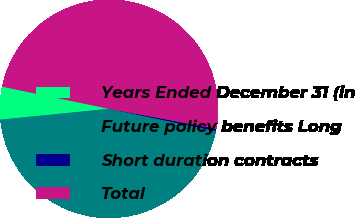<chart> <loc_0><loc_0><loc_500><loc_500><pie_chart><fcel>Years Ended December 31 (in<fcel>Future policy benefits Long<fcel>Short duration contracts<fcel>Total<nl><fcel>4.84%<fcel>45.16%<fcel>0.32%<fcel>49.68%<nl></chart> 